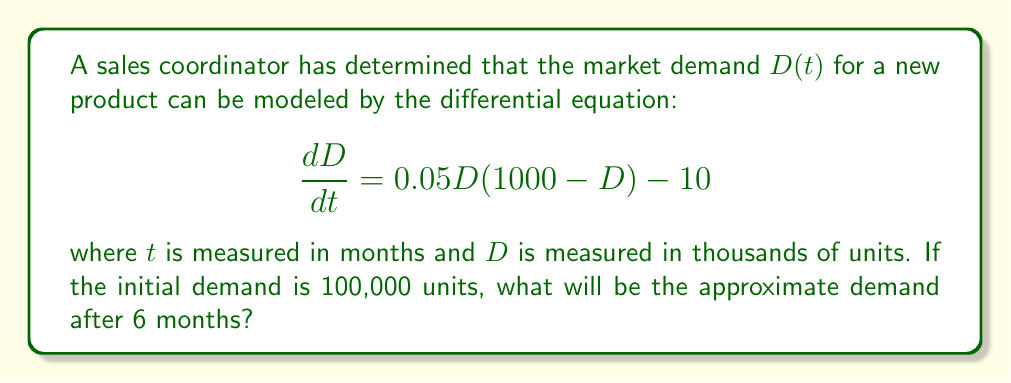Solve this math problem. To solve this problem, we'll follow these steps:

1) First, we need to identify the initial condition:
   $D(0) = 100$ (since D is measured in thousands of units)

2) The differential equation is non-linear and doesn't have a simple analytical solution. We'll use Euler's method to approximate the solution numerically.

3) Euler's method is given by:
   $D_{n+1} = D_n + h \cdot f(t_n, D_n)$
   where $h$ is the step size and $f(t, D) = 0.05D(1000 - D) - 10$

4) Let's use a step size of $h = 1$ month, so we'll calculate 6 steps:

   For $n = 0$:
   $D_1 = 100 + 1 \cdot (0.05 \cdot 100 \cdot (1000 - 100) - 10) = 144.5$

   For $n = 1$:
   $D_2 = 144.5 + 1 \cdot (0.05 \cdot 144.5 \cdot (1000 - 144.5) - 10) = 205.8125$

   For $n = 2$:
   $D_3 = 205.8125 + 1 \cdot (0.05 \cdot 205.8125 \cdot (1000 - 205.8125) - 10) = 282.6994$

   For $n = 3$:
   $D_4 = 282.6994 + 1 \cdot (0.05 \cdot 282.6994 \cdot (1000 - 282.6994) - 10) = 369.8315$

   For $n = 4$:
   $D_5 = 369.8315 + 1 \cdot (0.05 \cdot 369.8315 \cdot (1000 - 369.8315) - 10) = 460.9656$

   For $n = 5$:
   $D_6 = 460.9656 + 1 \cdot (0.05 \cdot 460.9656 \cdot (1000 - 460.9656) - 10) = 549.2735$

5) Therefore, after 6 months, the demand will be approximately 549,273 units.
Answer: 549,273 units 